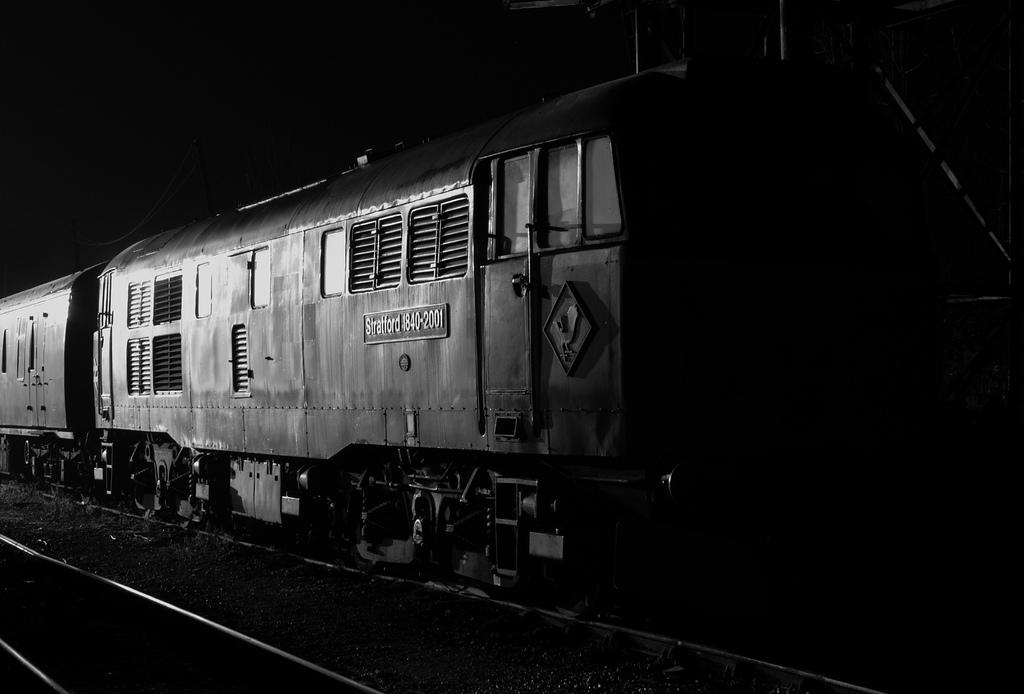What is the color scheme of the image? The image is black and white. Where was the image taken? The image was taken outdoors. What can be seen at the bottom of the image? There are railway tracks at the bottom of the image. What is the main subject in the middle of the image? There is a train in the middle of the image. What type of humor can be seen in the image? There is no humor present in the image; it is a black and white photograph of a train and railway tracks. Can you see a spoon in the image? No, there is no spoon visible in the image. 